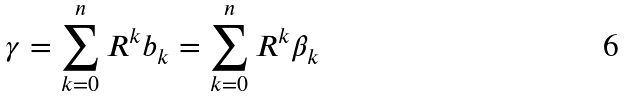Convert formula to latex. <formula><loc_0><loc_0><loc_500><loc_500>\gamma = \sum _ { k = 0 } ^ { n } R ^ { k } b _ { k } = \sum _ { k = 0 } ^ { n } R ^ { k } \beta _ { k }</formula> 